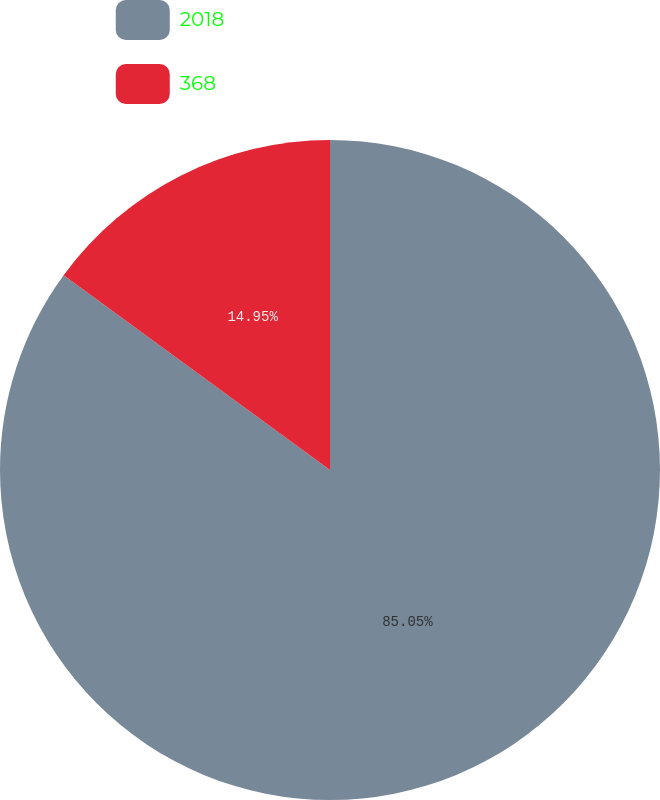Convert chart. <chart><loc_0><loc_0><loc_500><loc_500><pie_chart><fcel>2018<fcel>368<nl><fcel>85.05%<fcel>14.95%<nl></chart> 